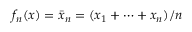Convert formula to latex. <formula><loc_0><loc_0><loc_500><loc_500>f _ { n } ( x ) = { \bar { x } } _ { n } = ( x _ { 1 } + \cdots + x _ { n } ) / n</formula> 